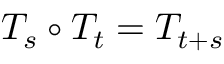Convert formula to latex. <formula><loc_0><loc_0><loc_500><loc_500>T _ { s } \circ T _ { t } = T _ { t + s }</formula> 